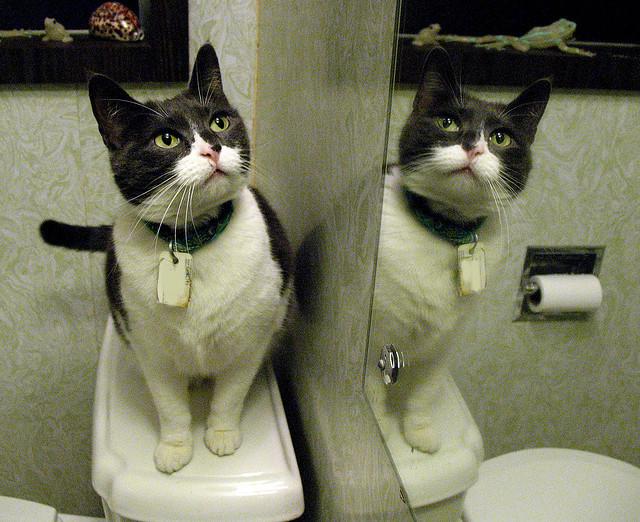Where was this photo taken?
Keep it brief. Bathroom. What is the paper product shown in the picture that will never be used by this animal?
Write a very short answer. Toilet paper. What animal is this?
Answer briefly. Cat. 